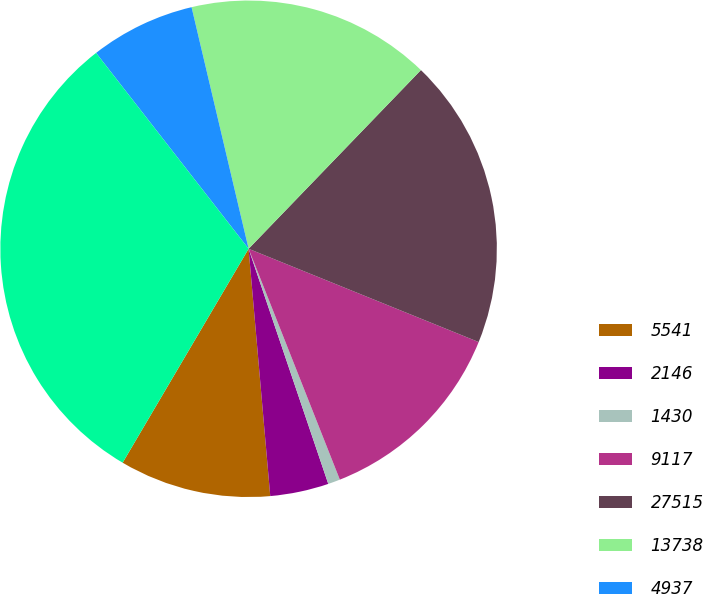Convert chart. <chart><loc_0><loc_0><loc_500><loc_500><pie_chart><fcel>5541<fcel>2146<fcel>1430<fcel>9117<fcel>27515<fcel>13738<fcel>4937<fcel>46190<nl><fcel>9.86%<fcel>3.81%<fcel>0.79%<fcel>12.88%<fcel>18.92%<fcel>15.9%<fcel>6.84%<fcel>31.0%<nl></chart> 